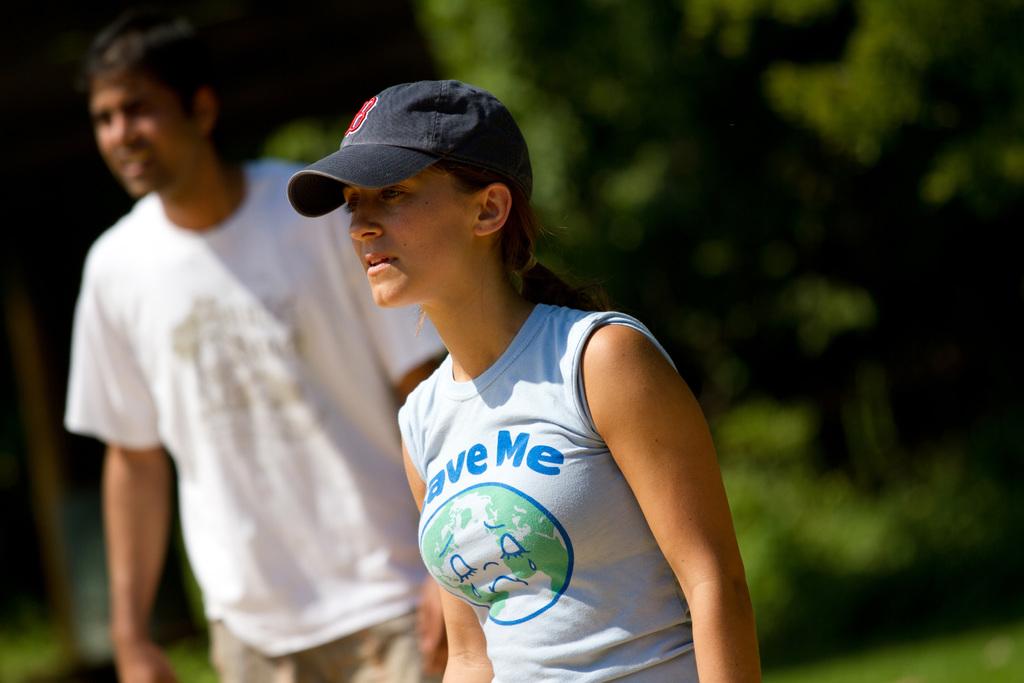What is the word on the right of the woman's shirt?
Provide a succinct answer. Me. 